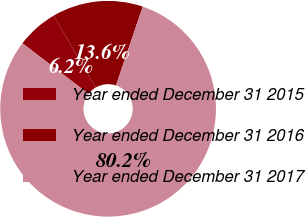Convert chart to OTSL. <chart><loc_0><loc_0><loc_500><loc_500><pie_chart><fcel>Year ended December 31 2015<fcel>Year ended December 31 2016<fcel>Year ended December 31 2017<nl><fcel>6.21%<fcel>13.61%<fcel>80.18%<nl></chart> 